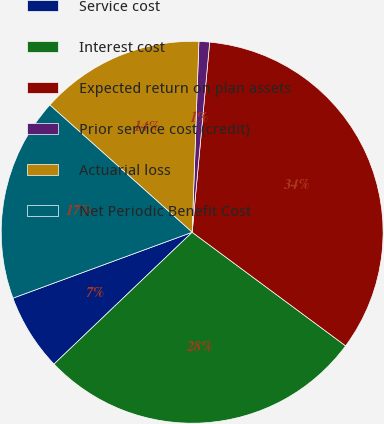Convert chart to OTSL. <chart><loc_0><loc_0><loc_500><loc_500><pie_chart><fcel>Service cost<fcel>Interest cost<fcel>Expected return on plan assets<fcel>Prior service cost (credit)<fcel>Actuarial loss<fcel>Net Periodic Benefit Cost<nl><fcel>6.52%<fcel>27.73%<fcel>33.68%<fcel>0.9%<fcel>13.95%<fcel>17.22%<nl></chart> 